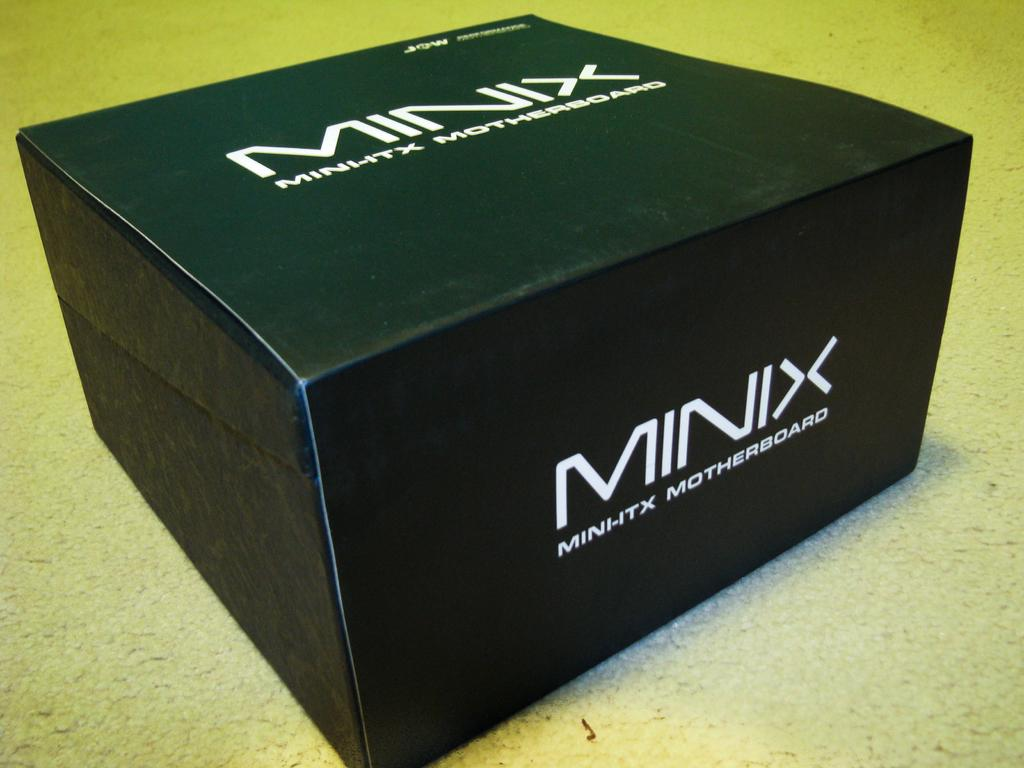<image>
Offer a succinct explanation of the picture presented. Black box with "Minix" lettered on the box in white. 